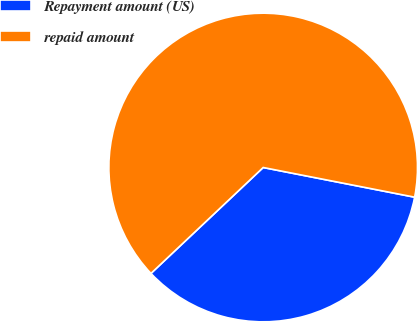Convert chart to OTSL. <chart><loc_0><loc_0><loc_500><loc_500><pie_chart><fcel>Repayment amount (US)<fcel>repaid amount<nl><fcel>34.88%<fcel>65.12%<nl></chart> 